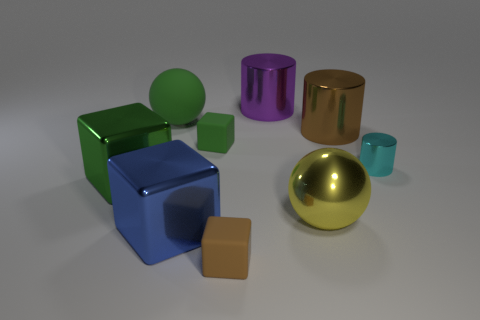Add 1 small matte balls. How many objects exist? 10 Subtract all balls. How many objects are left? 7 Add 9 small yellow things. How many small yellow things exist? 9 Subtract 1 blue cubes. How many objects are left? 8 Subtract all big purple objects. Subtract all shiny spheres. How many objects are left? 7 Add 1 large brown cylinders. How many large brown cylinders are left? 2 